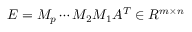<formula> <loc_0><loc_0><loc_500><loc_500>\begin{array} { r } { E = M _ { p } \cdots M _ { 2 } M _ { 1 } A ^ { T } \in R { ^ { m \times n } } } \end{array}</formula> 